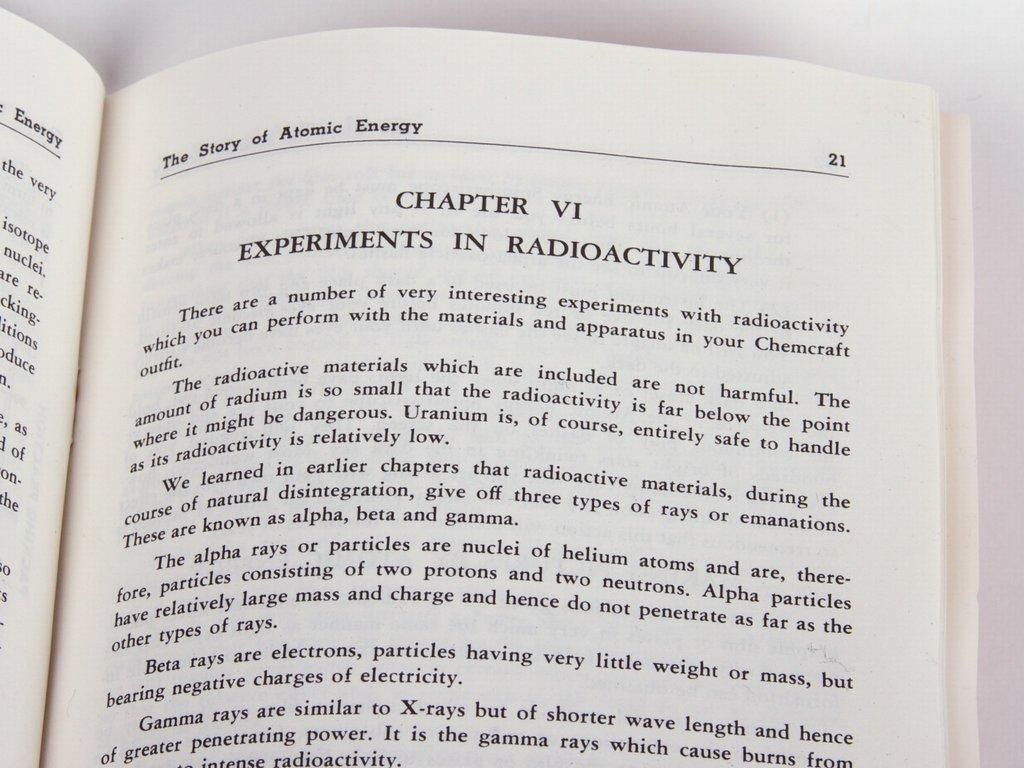<image>
Give a short and clear explanation of the subsequent image. A book about atomic energy, chapter VI lists experiments in radiocativity. 